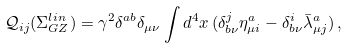<formula> <loc_0><loc_0><loc_500><loc_500>\mathcal { Q } _ { i j } ( \Sigma _ { G Z } ^ { l i n } ) = \gamma ^ { 2 } \delta ^ { a b } \delta _ { \mu \nu } \int d ^ { 4 } x \, ( \delta _ { b \nu } ^ { j } \eta _ { \mu i } ^ { a } - \delta _ { b \nu } ^ { i } \bar { \lambda } _ { \mu j } ^ { a } ) \, ,</formula> 